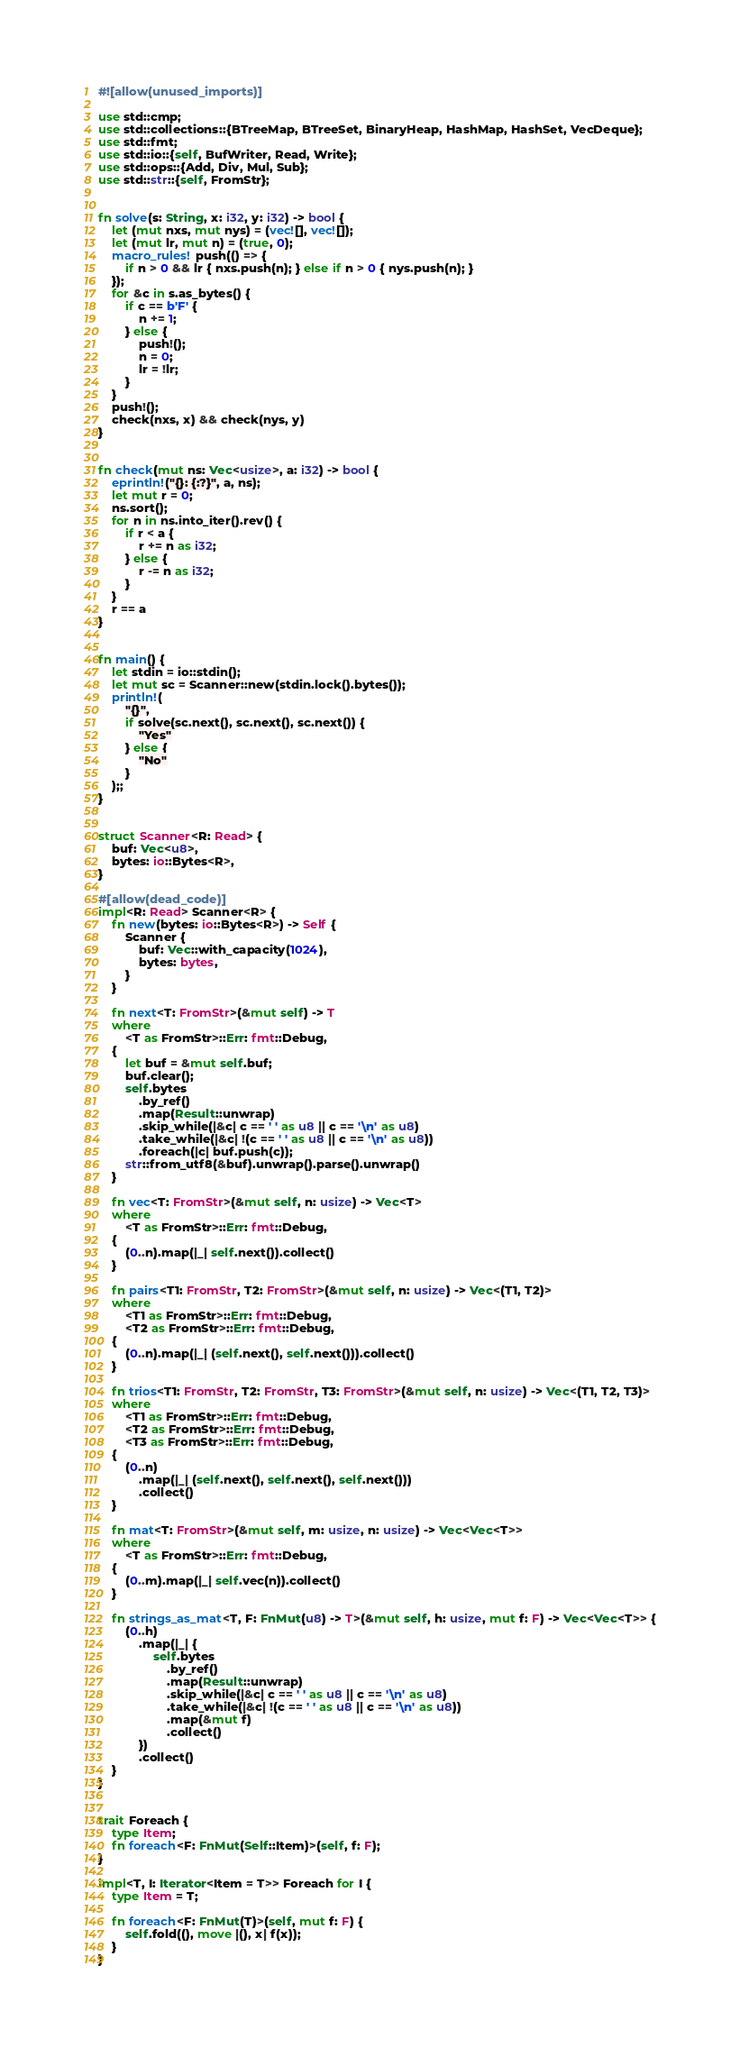Convert code to text. <code><loc_0><loc_0><loc_500><loc_500><_Rust_>#![allow(unused_imports)]

use std::cmp;
use std::collections::{BTreeMap, BTreeSet, BinaryHeap, HashMap, HashSet, VecDeque};
use std::fmt;
use std::io::{self, BufWriter, Read, Write};
use std::ops::{Add, Div, Mul, Sub};
use std::str::{self, FromStr};


fn solve(s: String, x: i32, y: i32) -> bool {
    let (mut nxs, mut nys) = (vec![], vec![]);
    let (mut lr, mut n) = (true, 0);
    macro_rules! push(() => {
        if n > 0 && lr { nxs.push(n); } else if n > 0 { nys.push(n); }
    });
    for &c in s.as_bytes() {
        if c == b'F' {
            n += 1;
        } else {
            push!();
            n = 0;
            lr = !lr;
        }
    }
    push!();
    check(nxs, x) && check(nys, y)
}


fn check(mut ns: Vec<usize>, a: i32) -> bool {
    eprintln!("{}: {:?}", a, ns);
    let mut r = 0;
    ns.sort();
    for n in ns.into_iter().rev() {
        if r < a {
            r += n as i32;
        } else {
            r -= n as i32;
        }
    }
    r == a
}


fn main() {
    let stdin = io::stdin();
    let mut sc = Scanner::new(stdin.lock().bytes());
    println!(
        "{}",
        if solve(sc.next(), sc.next(), sc.next()) {
            "Yes"
        } else {
            "No"
        }
    );;
}


struct Scanner<R: Read> {
    buf: Vec<u8>,
    bytes: io::Bytes<R>,
}

#[allow(dead_code)]
impl<R: Read> Scanner<R> {
    fn new(bytes: io::Bytes<R>) -> Self {
        Scanner {
            buf: Vec::with_capacity(1024),
            bytes: bytes,
        }
    }

    fn next<T: FromStr>(&mut self) -> T
    where
        <T as FromStr>::Err: fmt::Debug,
    {
        let buf = &mut self.buf;
        buf.clear();
        self.bytes
            .by_ref()
            .map(Result::unwrap)
            .skip_while(|&c| c == ' ' as u8 || c == '\n' as u8)
            .take_while(|&c| !(c == ' ' as u8 || c == '\n' as u8))
            .foreach(|c| buf.push(c));
        str::from_utf8(&buf).unwrap().parse().unwrap()
    }

    fn vec<T: FromStr>(&mut self, n: usize) -> Vec<T>
    where
        <T as FromStr>::Err: fmt::Debug,
    {
        (0..n).map(|_| self.next()).collect()
    }

    fn pairs<T1: FromStr, T2: FromStr>(&mut self, n: usize) -> Vec<(T1, T2)>
    where
        <T1 as FromStr>::Err: fmt::Debug,
        <T2 as FromStr>::Err: fmt::Debug,
    {
        (0..n).map(|_| (self.next(), self.next())).collect()
    }

    fn trios<T1: FromStr, T2: FromStr, T3: FromStr>(&mut self, n: usize) -> Vec<(T1, T2, T3)>
    where
        <T1 as FromStr>::Err: fmt::Debug,
        <T2 as FromStr>::Err: fmt::Debug,
        <T3 as FromStr>::Err: fmt::Debug,
    {
        (0..n)
            .map(|_| (self.next(), self.next(), self.next()))
            .collect()
    }

    fn mat<T: FromStr>(&mut self, m: usize, n: usize) -> Vec<Vec<T>>
    where
        <T as FromStr>::Err: fmt::Debug,
    {
        (0..m).map(|_| self.vec(n)).collect()
    }

    fn strings_as_mat<T, F: FnMut(u8) -> T>(&mut self, h: usize, mut f: F) -> Vec<Vec<T>> {
        (0..h)
            .map(|_| {
                self.bytes
                    .by_ref()
                    .map(Result::unwrap)
                    .skip_while(|&c| c == ' ' as u8 || c == '\n' as u8)
                    .take_while(|&c| !(c == ' ' as u8 || c == '\n' as u8))
                    .map(&mut f)
                    .collect()
            })
            .collect()
    }
}


trait Foreach {
    type Item;
    fn foreach<F: FnMut(Self::Item)>(self, f: F);
}

impl<T, I: Iterator<Item = T>> Foreach for I {
    type Item = T;

    fn foreach<F: FnMut(T)>(self, mut f: F) {
        self.fold((), move |(), x| f(x));
    }
}
</code> 